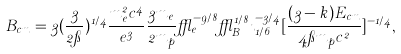<formula> <loc_0><loc_0><loc_500><loc_500>B _ { c m } = 3 ( \frac { 3 } { 2 \pi } ) ^ { 1 / 4 } \frac { m _ { e } ^ { 2 } c ^ { 4 } } { e ^ { 3 } } \frac { 3 m _ { e } } { 2 m _ { p } } \epsilon _ { e } ^ { - 9 / 8 } \epsilon _ { B } ^ { 1 / 8 } \zeta _ { 1 / 6 } ^ { - 3 / 4 } [ \frac { ( 3 - k ) E _ { c m } } { 4 \pi m _ { p } c ^ { 2 } } ] ^ { - 1 / 4 } ,</formula> 